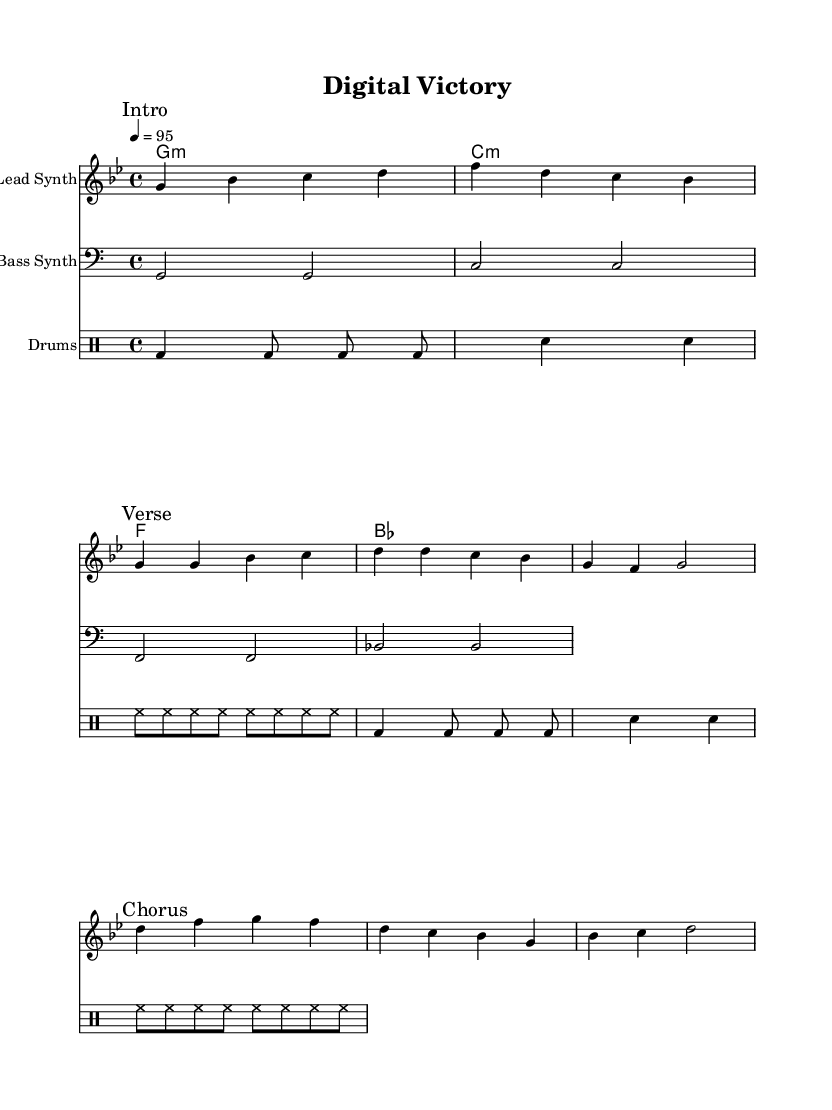What is the key signature of this music? The key signature is G minor, indicated by two flats (B flat and E flat). This information can be found at the beginning of the staff, shown with the flat symbols.
Answer: G minor What is the time signature of the piece? The time signature is 4/4, meaning there are four beats in each measure and the quarter note gets one beat. This can be identified at the beginning of the score, right next to the key signature.
Answer: 4/4 What is the tempo marking of the song? The tempo is marked as 4 = 95, indicating that the quarter note should be played at a speed of 95 beats per minute. This tempo is specified at the beginning of the score above the staff.
Answer: 95 How many measures are in the melody section? The melody section from the "Intro" to the "Chorus" covers a total of six measures. By counting the vertical bar lines in the provided melody, you can see the divisions of the measures.
Answer: 6 measures Which instrument plays the bass line? The bass line is played by the "Bass Synth," which is specified in the staff label just before the bass line begins. This information identifies the staff and the corresponding instrument.
Answer: Bass Synth What kind of rhythm pattern is represented in the drums part? The drums part features a combination of bass drum (bd), snare drum (sn), and hi-hat (hh), characterized by a repetitive and structured rhythm pattern typical for energy in hip hop. You can identify these distinct patterns from the notation under the drum staff.
Answer: Repetitive rhythm What is the main focus or theme of this anthem? The anthem celebrates successful digital marketing campaigns, which is reflected in its energetic style and structure, making it conducive to relating to triumphs in digital marketing. This theme is derived from the title "Digital Victory" and the overall vibe of the sheet music.
Answer: Celebrating success 